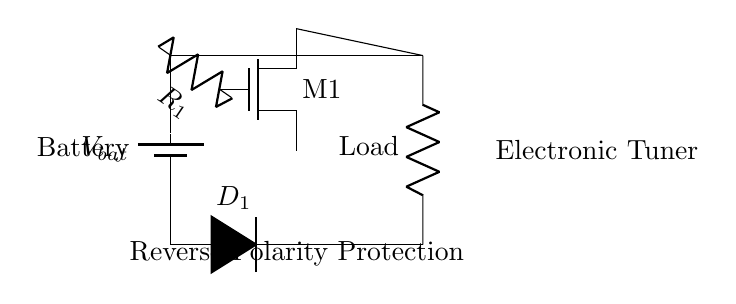What type of transistor is M1? M1 is labeled as an NMOS transistor in the circuit diagram, which can be identified by the symbol used (an arrow pointing to the gate).
Answer: NMOS What does D1 do in this circuit? D1 serves as a diode providing reverse polarity protection by blocking reverse current when the battery is connected incorrectly.
Answer: Block reverse current How many components are connected to the load? The load is connected to two components: the NMOS transistor (M1) and the resistor (R1).
Answer: Two components What is the role of R1 in this circuit? R1 limits the current flowing from the drain of the NMOS transistor, preventing excessive current that could damage the circuit components.
Answer: Current limiter What happens if the battery is connected with reverse polarity? If the battery is connected with reverse polarity, D1 will prevent current from flowing and protect the rest of the circuit from damage.
Answer: Current is blocked What is the total number of components in the circuit? The circuit contains five components: one battery, one NMOS transistor, one resistor, one diode, and one load.
Answer: Five components What is the main purpose of this circuit? The main purpose of this circuit is to provide reverse polarity protection, ensuring the device operates safely when connected to a battery.
Answer: Reverse polarity protection 